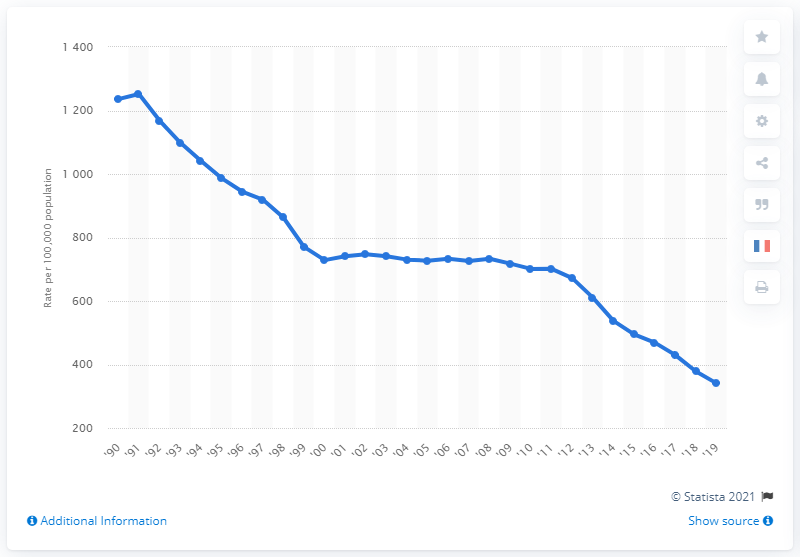Indicate a few pertinent items in this graphic. In 2019, the burglary rate per 100,000 people was approximately 340.5. 